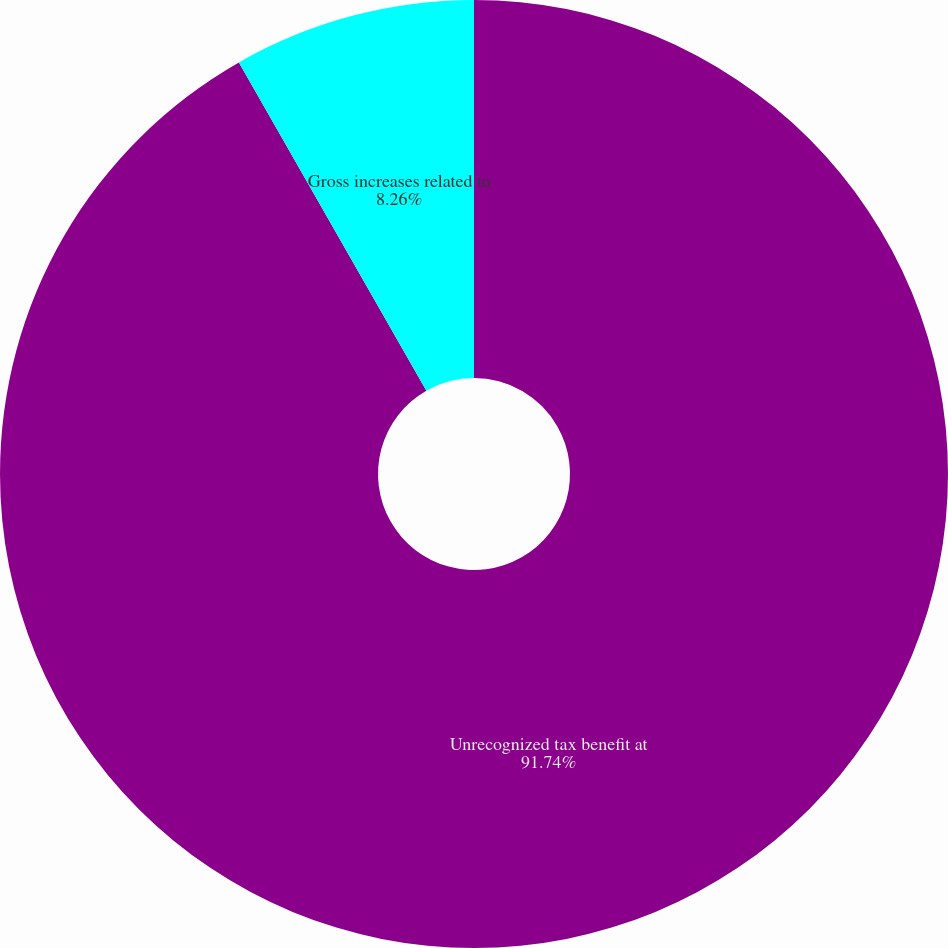Convert chart. <chart><loc_0><loc_0><loc_500><loc_500><pie_chart><fcel>Unrecognized tax benefit at<fcel>Gross increases related to<nl><fcel>91.74%<fcel>8.26%<nl></chart> 